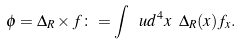<formula> <loc_0><loc_0><loc_500><loc_500>\phi = \Delta _ { R } \times f \colon = \int \ u d ^ { 4 } x \ \Delta _ { R } ( x ) f _ { x } .</formula> 